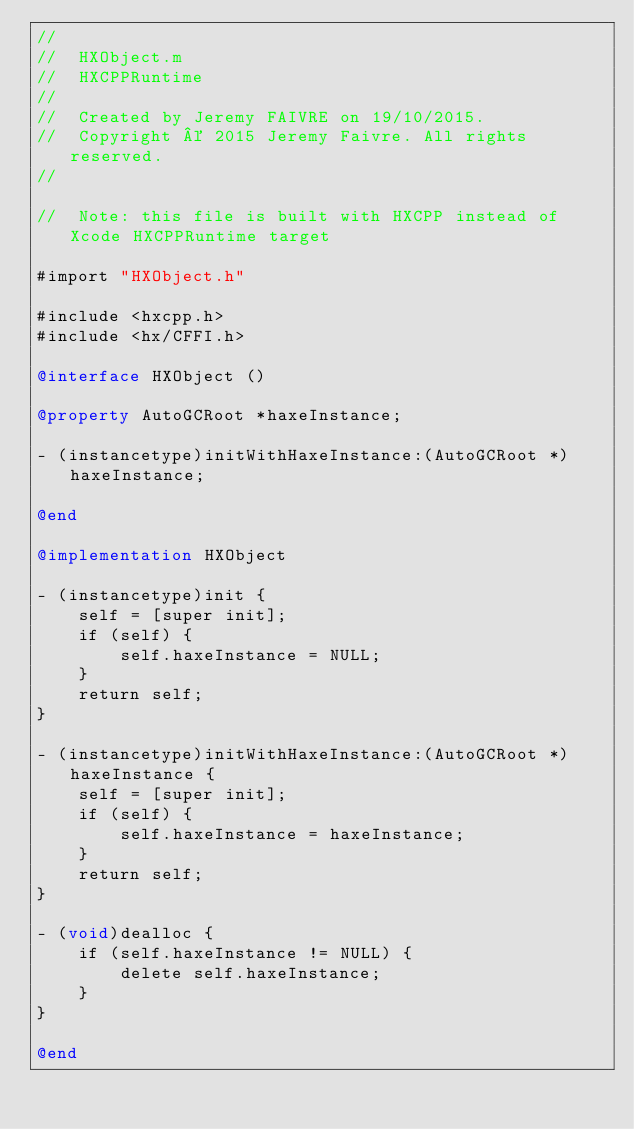<code> <loc_0><loc_0><loc_500><loc_500><_ObjectiveC_>//
//  HXObject.m
//  HXCPPRuntime
//
//  Created by Jeremy FAIVRE on 19/10/2015.
//  Copyright © 2015 Jeremy Faivre. All rights reserved.
//

//  Note: this file is built with HXCPP instead of Xcode HXCPPRuntime target

#import "HXObject.h"

#include <hxcpp.h>
#include <hx/CFFI.h>

@interface HXObject ()

@property AutoGCRoot *haxeInstance;

- (instancetype)initWithHaxeInstance:(AutoGCRoot *)haxeInstance;

@end

@implementation HXObject

- (instancetype)init {
    self = [super init];
    if (self) {
        self.haxeInstance = NULL;
    }
    return self;
}

- (instancetype)initWithHaxeInstance:(AutoGCRoot *)haxeInstance {
    self = [super init];
    if (self) {
        self.haxeInstance = haxeInstance;
    }
    return self;
}

- (void)dealloc {
    if (self.haxeInstance != NULL) {
        delete self.haxeInstance;
    }
}

@end
</code> 